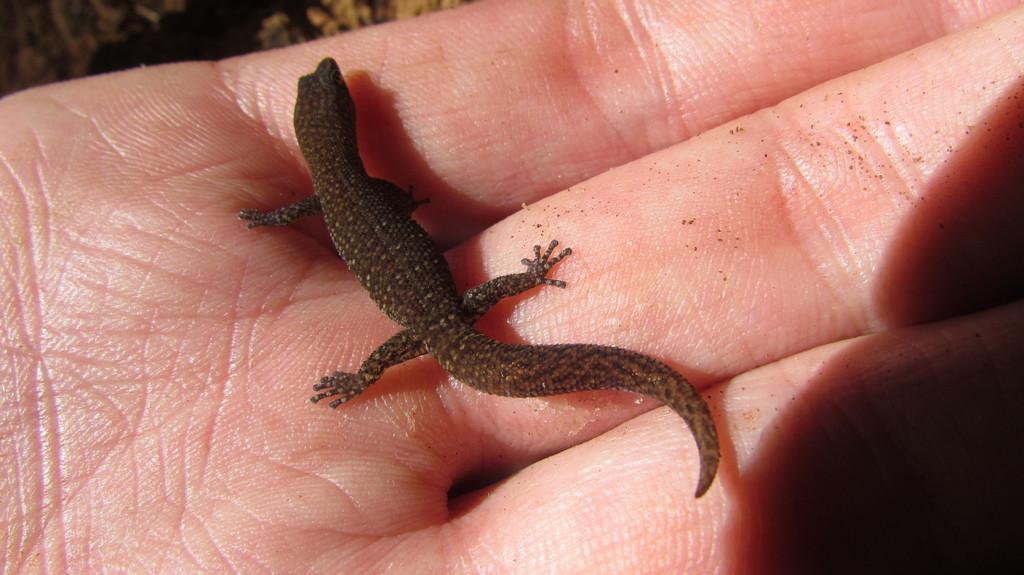Describe this image in one or two sentences. This image consists of a hand. On that there is a lizard. It is in black color. 